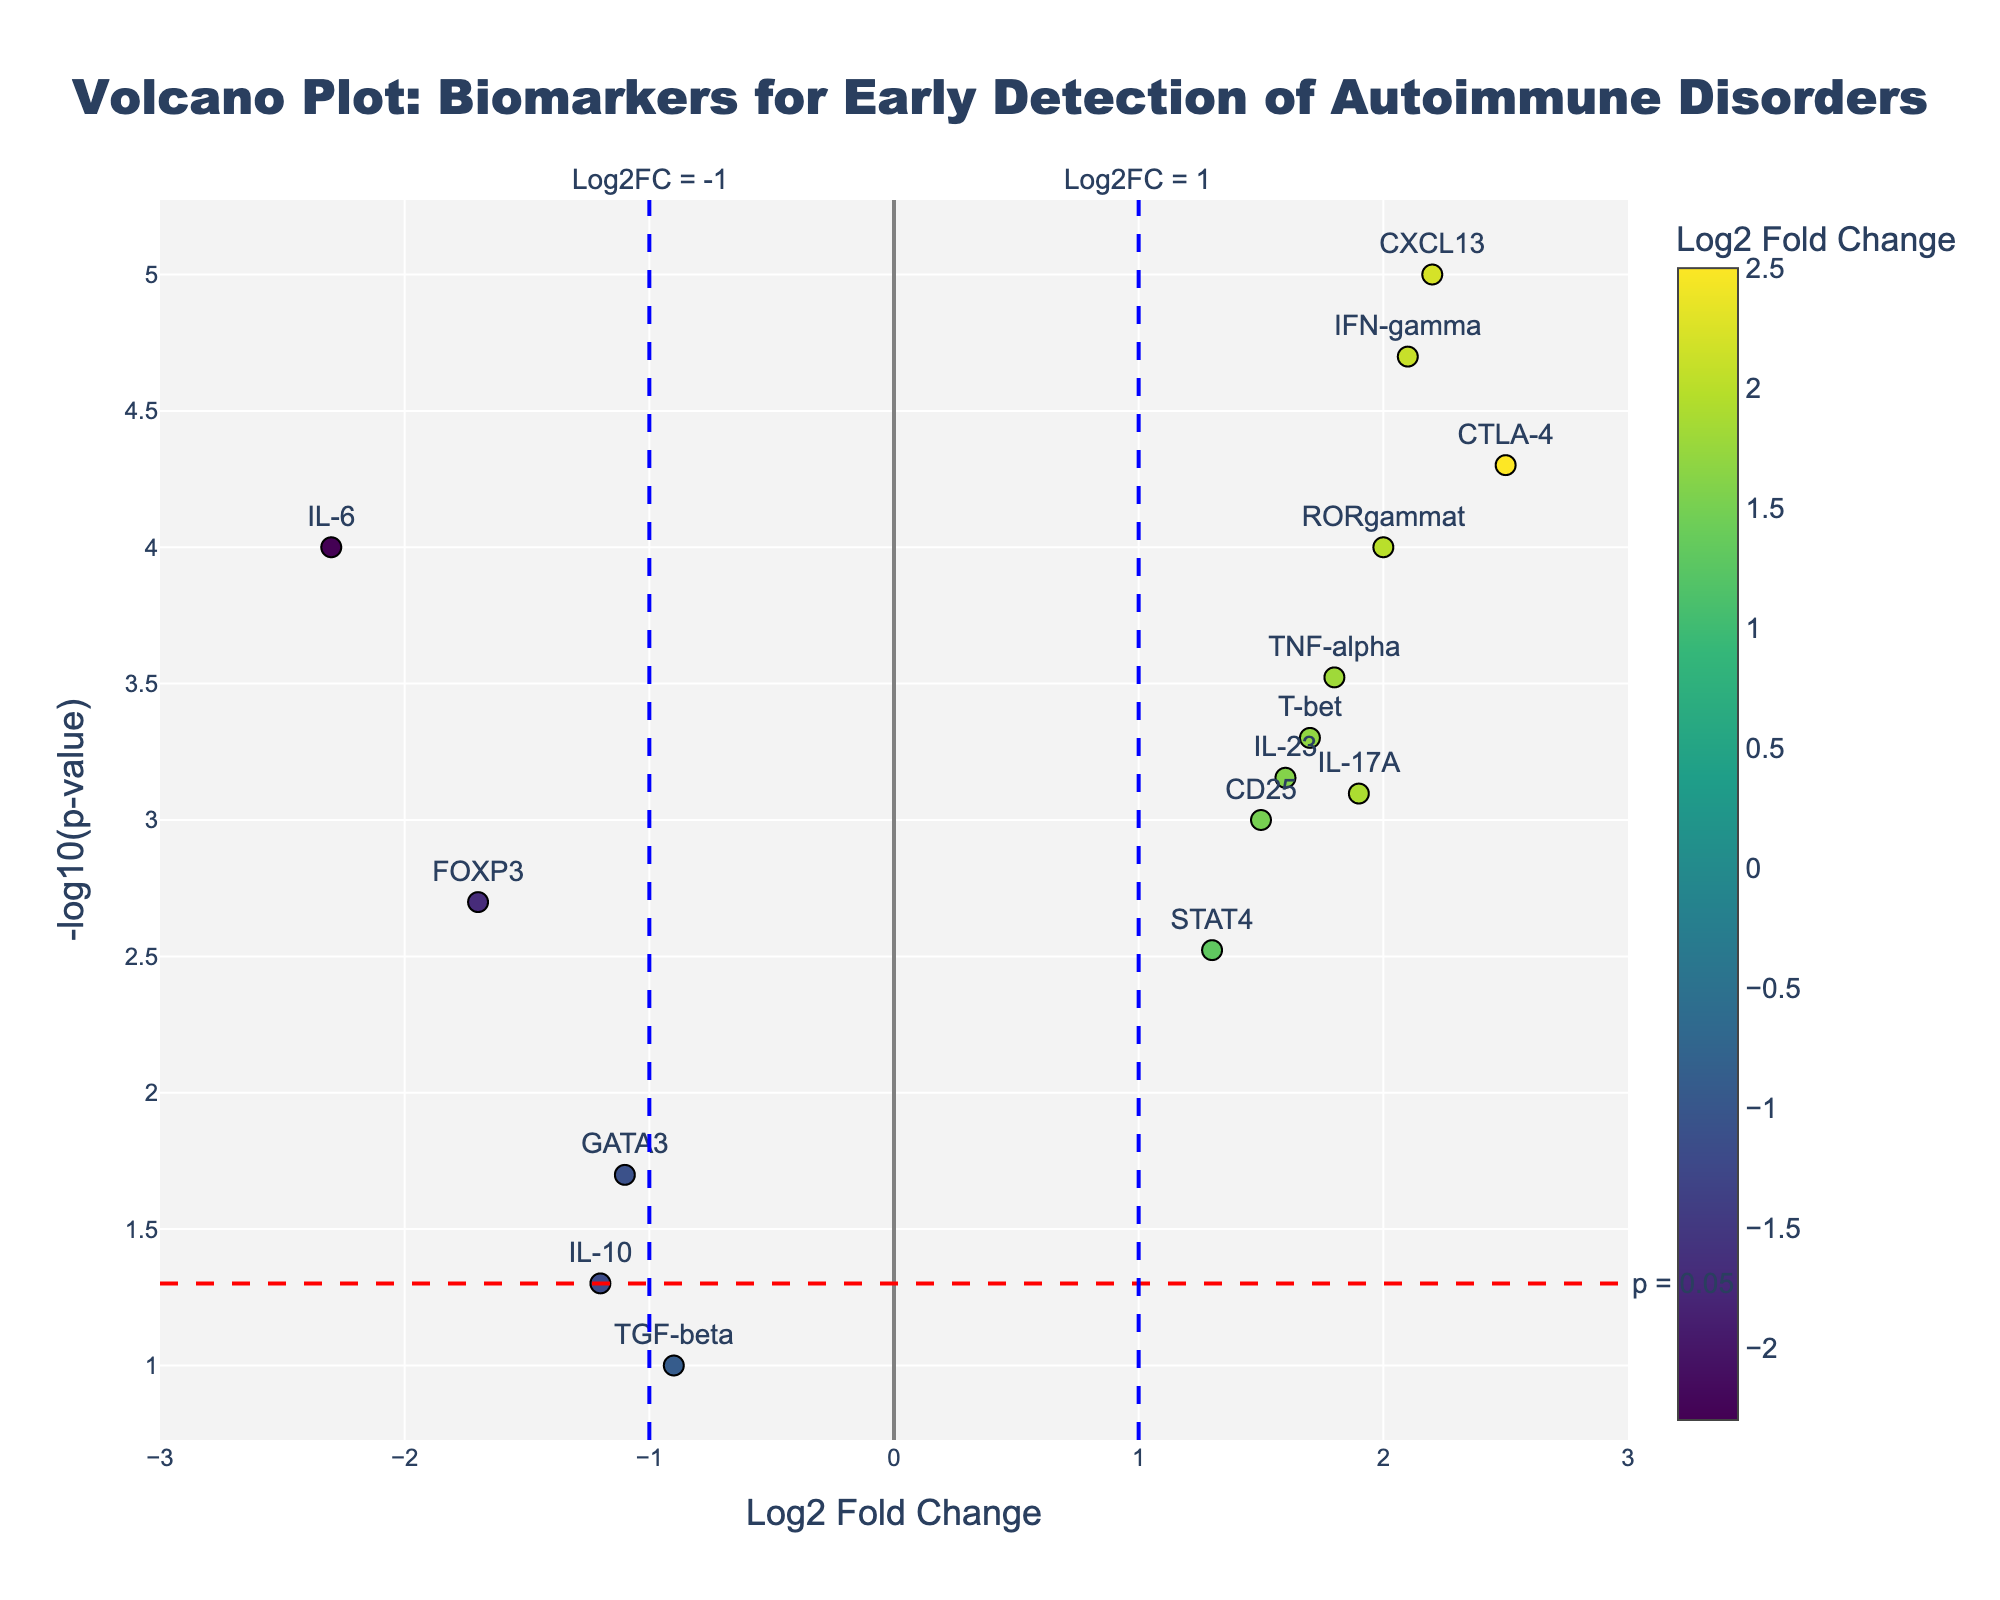What's the title of the plot? The title is prominently displayed at the top of the plot.
Answer: Volcano Plot: Biomarkers for Early Detection of Autoimmune Disorders What does the y-axis represent? The y-axis represents the negative logarithm (base 10) of the p-value. This information is given in the axis title which states "-log10(p-value)".
Answer: -log10(p-value) How many genes have a log2 fold change greater than 2? Look for data points with Log2 Fold Change values greater than 2 on the x-axis and count them.
Answer: 3 Which gene has the highest -log10(p-value) value? Identify the highest point on the y-axis and check the label for the corresponding gene.
Answer: CXCL13 What's the log2 fold change value for IL-6? Find the data point labeled "IL-6" and read its x-axis value.
Answer: -2.3 What are the thresholds for significance in this plot? The plot shows red and blue dashed lines for significance thresholds. There are three lines: one horizontal at -log10(0.05) for p-value significance, and two vertical lines at log2 fold changes of -1 and 1.
Answer: p = 0.05, Log2FC = -1, Log2FC = 1 Are more genes upregulated or downregulated based on Log2 Fold Change? Upregulated genes have positive Log2 Fold Change values, and downregulated genes have negative values. Compare the number of points on either side of the vertical dashed line at 0.
Answer: More upregulated Which gene has a lower p-value, TNF-alpha or IL-17A? Compare the positions of TNF-alpha and IL-17A on the y-axis. Higher -log10(p-value) means a lower p-value.
Answer: TNF-alpha Which gene has the closest Log2 Fold Change value to -1? Look for the data point closest to the vertical dashed line at Log2FC = -1.
Answer: FOXP3 What does a higher position on the y-axis indicate about a gene’s statistical significance? The y-axis represents -log10(p-value); therefore, a higher position means a lower p-value and higher statistical significance.
Answer: Higher significance 